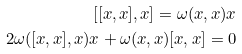Convert formula to latex. <formula><loc_0><loc_0><loc_500><loc_500>[ [ x , x ] , x ] = \omega ( x , x ) x \\ 2 \omega ( [ x , x ] , x ) x + \omega ( x , x ) [ x , x ] = 0</formula> 